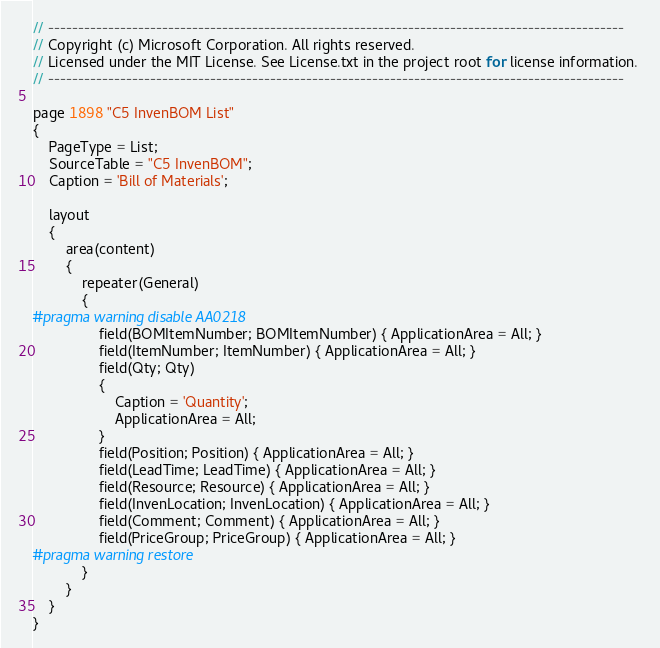<code> <loc_0><loc_0><loc_500><loc_500><_Perl_>// ------------------------------------------------------------------------------------------------
// Copyright (c) Microsoft Corporation. All rights reserved. 
// Licensed under the MIT License. See License.txt in the project root for license information. 
// ------------------------------------------------------------------------------------------------

page 1898 "C5 InvenBOM List"
{
    PageType = List;
    SourceTable = "C5 InvenBOM";
    Caption = 'Bill of Materials';

    layout
    {
        area(content)
        {
            repeater(General)
            {
#pragma warning disable AA0218
                field(BOMItemNumber; BOMItemNumber) { ApplicationArea = All; }
                field(ItemNumber; ItemNumber) { ApplicationArea = All; }
                field(Qty; Qty)
                {
                    Caption = 'Quantity';
                    ApplicationArea = All;
                }
                field(Position; Position) { ApplicationArea = All; }
                field(LeadTime; LeadTime) { ApplicationArea = All; }
                field(Resource; Resource) { ApplicationArea = All; }
                field(InvenLocation; InvenLocation) { ApplicationArea = All; }
                field(Comment; Comment) { ApplicationArea = All; }
                field(PriceGroup; PriceGroup) { ApplicationArea = All; }
#pragma warning restore
            }
        }
    }
}</code> 